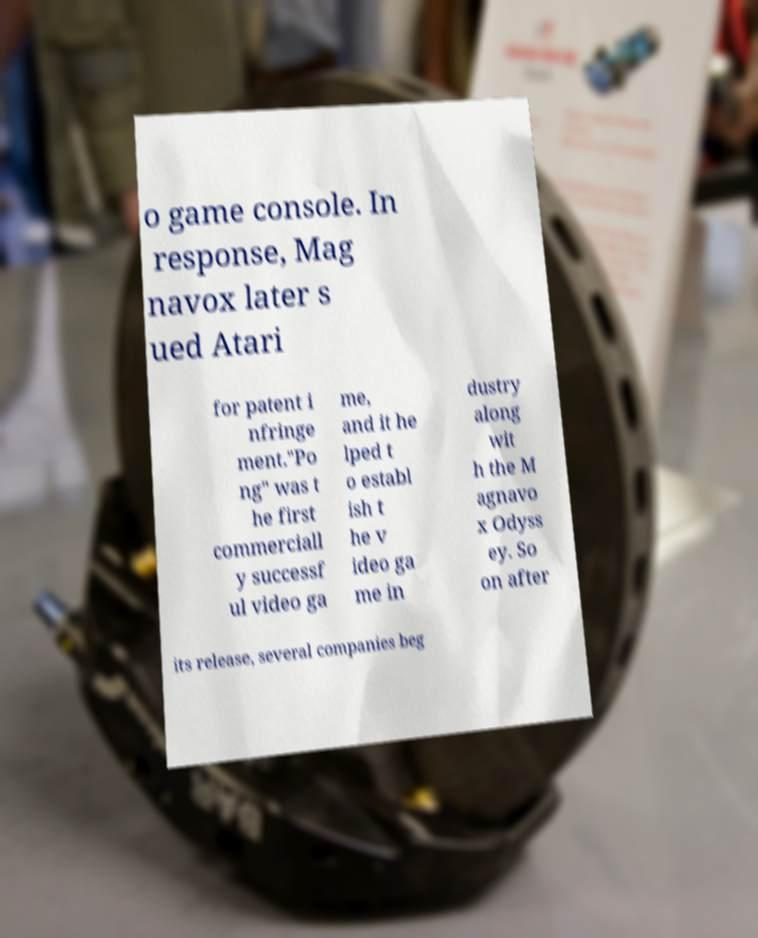There's text embedded in this image that I need extracted. Can you transcribe it verbatim? o game console. In response, Mag navox later s ued Atari for patent i nfringe ment."Po ng" was t he first commerciall y successf ul video ga me, and it he lped t o establ ish t he v ideo ga me in dustry along wit h the M agnavo x Odyss ey. So on after its release, several companies beg 